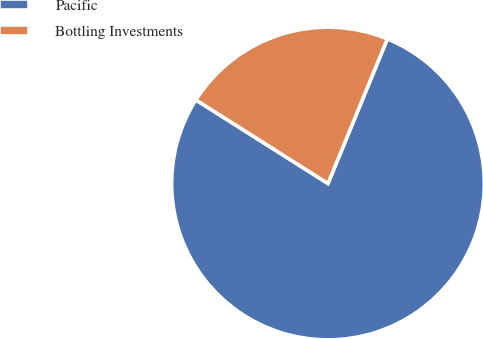<chart> <loc_0><loc_0><loc_500><loc_500><pie_chart><fcel>Pacific<fcel>Bottling Investments<nl><fcel>77.78%<fcel>22.22%<nl></chart> 